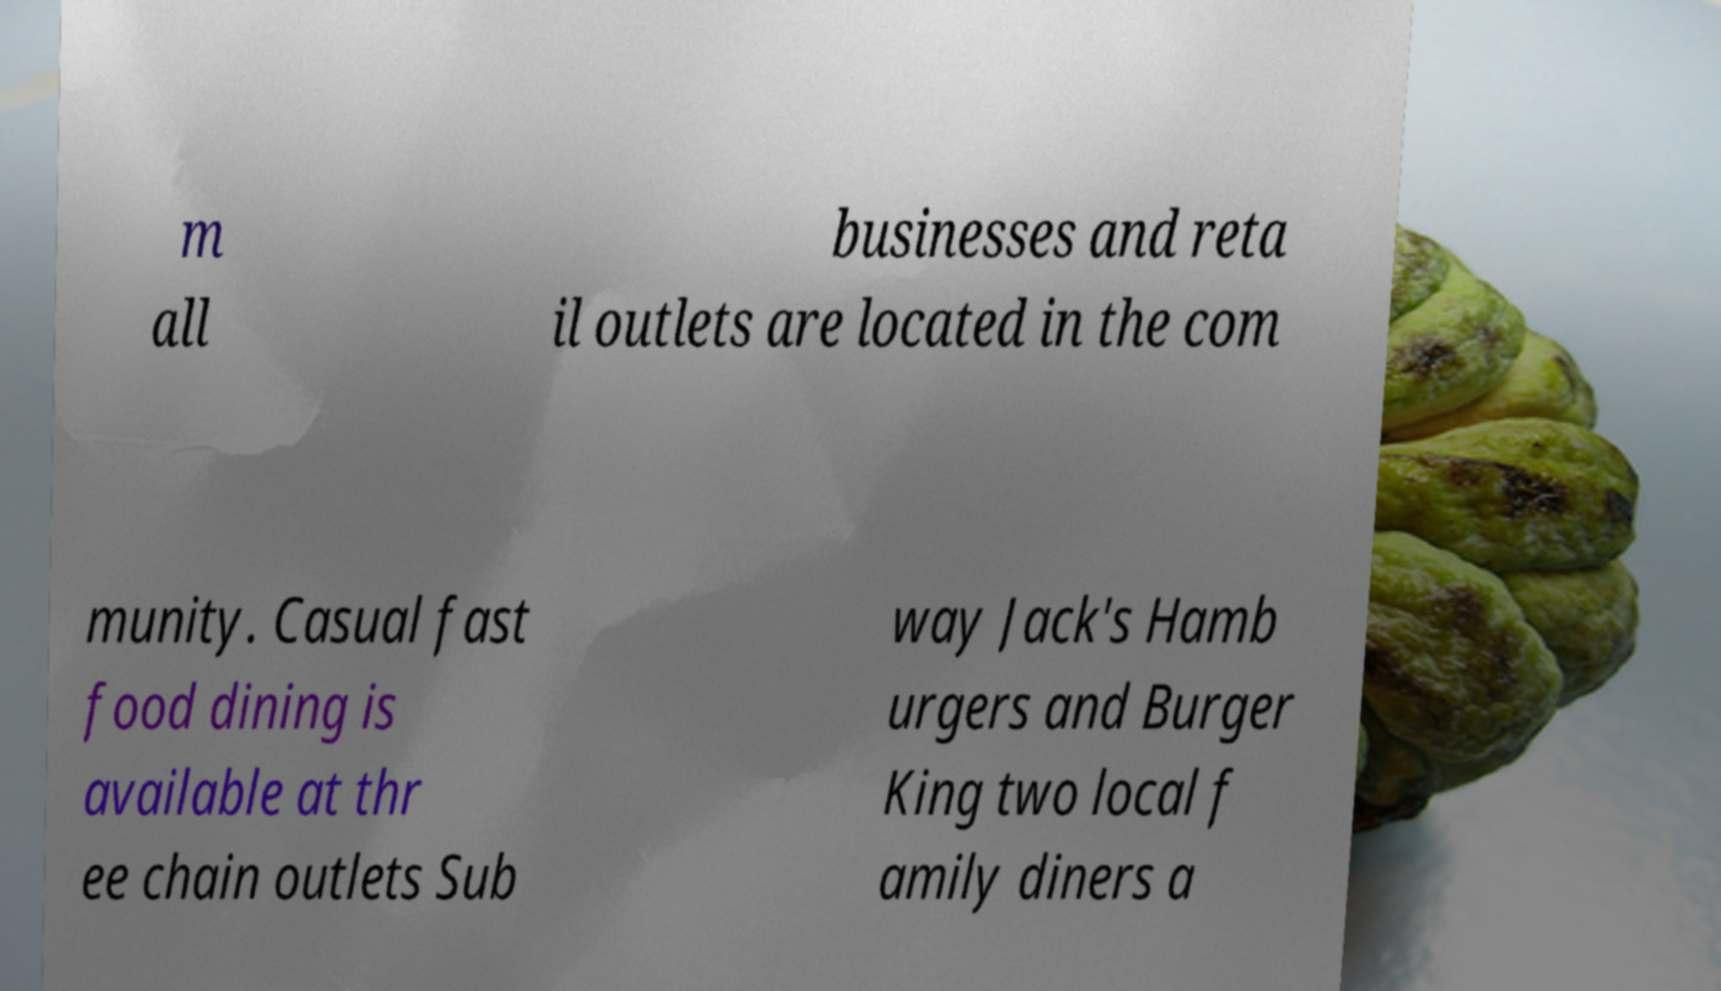I need the written content from this picture converted into text. Can you do that? m all businesses and reta il outlets are located in the com munity. Casual fast food dining is available at thr ee chain outlets Sub way Jack's Hamb urgers and Burger King two local f amily diners a 